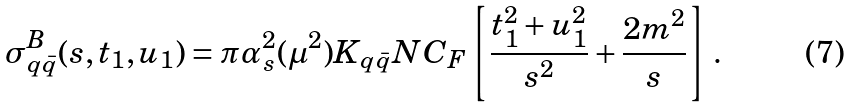<formula> <loc_0><loc_0><loc_500><loc_500>\sigma ^ { B } _ { q \bar { q } } ( s , t _ { 1 } , u _ { 1 } ) = \pi \alpha _ { s } ^ { 2 } ( \mu ^ { 2 } ) K _ { q \bar { q } } N C _ { F } \left [ \frac { t _ { 1 } ^ { 2 } + u _ { 1 } ^ { 2 } } { s ^ { 2 } } + \frac { 2 m ^ { 2 } } { s } \right ] \, .</formula> 